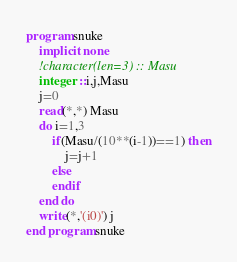Convert code to text. <code><loc_0><loc_0><loc_500><loc_500><_FORTRAN_>program snuke
	implicit none
	!character(len=3) :: Masu
    integer ::i,j,Masu
    j=0
    read(*,*) Masu
  	do i=1,3
    	if(Masu/(10**(i-1))==1) then
     		j=j+1
        else
        endif
	end do   
    write(*,'(i0)') j
end program snuke</code> 